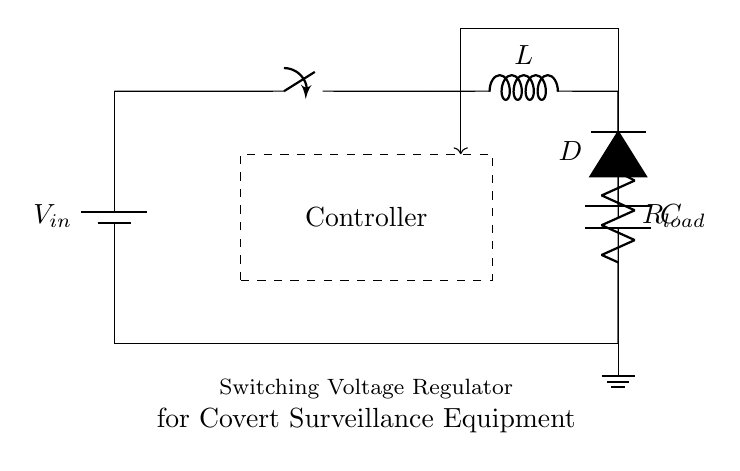What is the input voltage source in this circuit? The input voltage source is labeled as V_{in}, which indicates where the power supply connects to the circuit.
Answer: V_{in} What component stores energy in this circuit? The component that stores energy in this circuit is the inductor, represented as L. Inductors store energy in a magnetic field when current flows through them.
Answer: L What is the purpose of the diode in this circuit? The diode, labeled as D, allows current to flow in one direction while blocking it in the opposite direction. In this regulator, it helps to prevent backflow of current which can damage the circuit.
Answer: Prevents backflow Which component is responsible for smoothing the output voltage? The capacitor, labeled as C, is responsible for smoothing the output voltage by storing charge and releasing it to maintain stable voltage levels.
Answer: C Why is there a feedback line in the circuit? The feedback line connects the output of the regulator back to the controller. It allows the controller to monitor the output voltage and adjust the switching action to maintain a consistent voltage, which is critical for efficient operation.
Answer: To monitor output voltage What is the load represented in this circuit? The load is represented by the resistor labeled as R_{load}. This component indicates the part of the circuit that consumes power or receives the output voltage from the regulator.
Answer: R_{load} What type of regulator is depicted in the circuit? The circuit depicted is a switching voltage regulator, which is designed to efficiently convert a higher input voltage to a lower output voltage while maximizing battery life in covert surveillance equipment.
Answer: Switching voltage regulator 